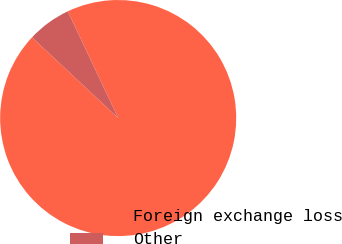<chart> <loc_0><loc_0><loc_500><loc_500><pie_chart><fcel>Foreign exchange loss<fcel>Other<nl><fcel>94.0%<fcel>6.0%<nl></chart> 